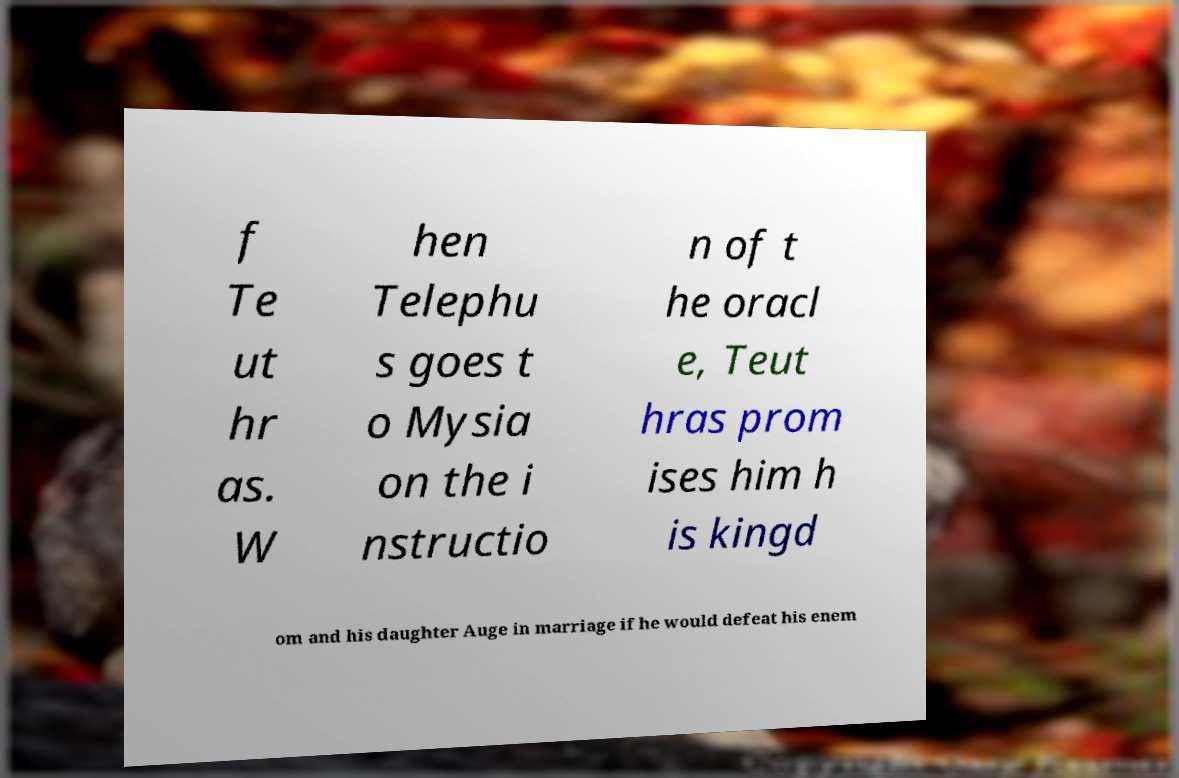Please identify and transcribe the text found in this image. f Te ut hr as. W hen Telephu s goes t o Mysia on the i nstructio n of t he oracl e, Teut hras prom ises him h is kingd om and his daughter Auge in marriage if he would defeat his enem 